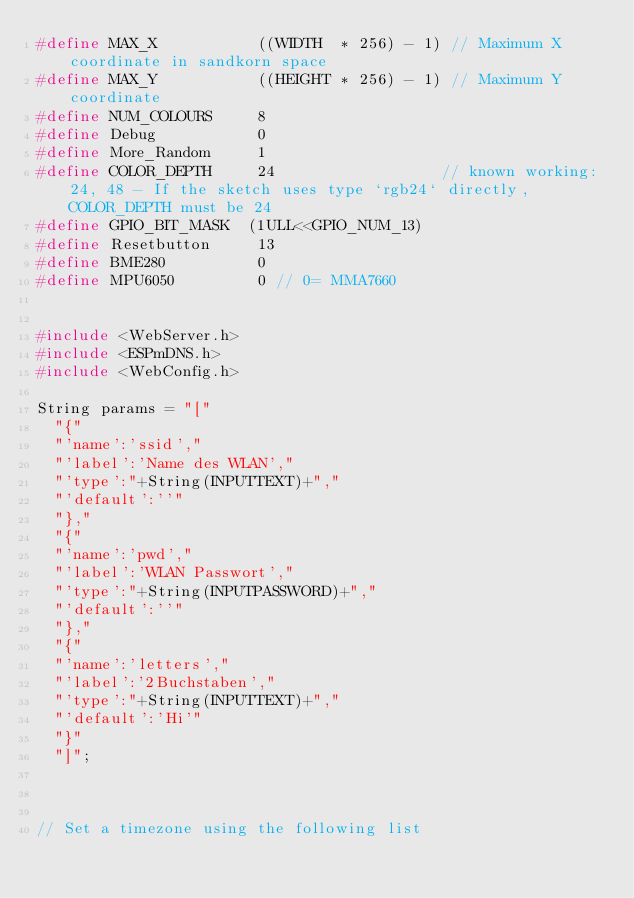<code> <loc_0><loc_0><loc_500><loc_500><_C_>#define MAX_X           ((WIDTH  * 256) - 1) // Maximum X coordinate in sandkorn space
#define MAX_Y           ((HEIGHT * 256) - 1) // Maximum Y coordinate
#define NUM_COLOURS     8
#define Debug           0
#define More_Random     1
#define COLOR_DEPTH     24                  // known working: 24, 48 - If the sketch uses type `rgb24` directly, COLOR_DEPTH must be 24
#define GPIO_BIT_MASK  (1ULL<<GPIO_NUM_13)
#define Resetbutton     13
#define BME280          0
#define MPU6050         0 // 0= MMA7660


#include <WebServer.h>
#include <ESPmDNS.h>
#include <WebConfig.h>

String params = "["
  "{"
  "'name':'ssid',"
  "'label':'Name des WLAN',"
  "'type':"+String(INPUTTEXT)+","
  "'default':''"
  "},"
  "{"
  "'name':'pwd',"
  "'label':'WLAN Passwort',"
  "'type':"+String(INPUTPASSWORD)+","
  "'default':''"
  "},"
  "{"
  "'name':'letters',"
  "'label':'2Buchstaben',"
  "'type':"+String(INPUTTEXT)+","
  "'default':'Hi'"
  "}"
  "]";



// Set a timezone using the following list</code> 